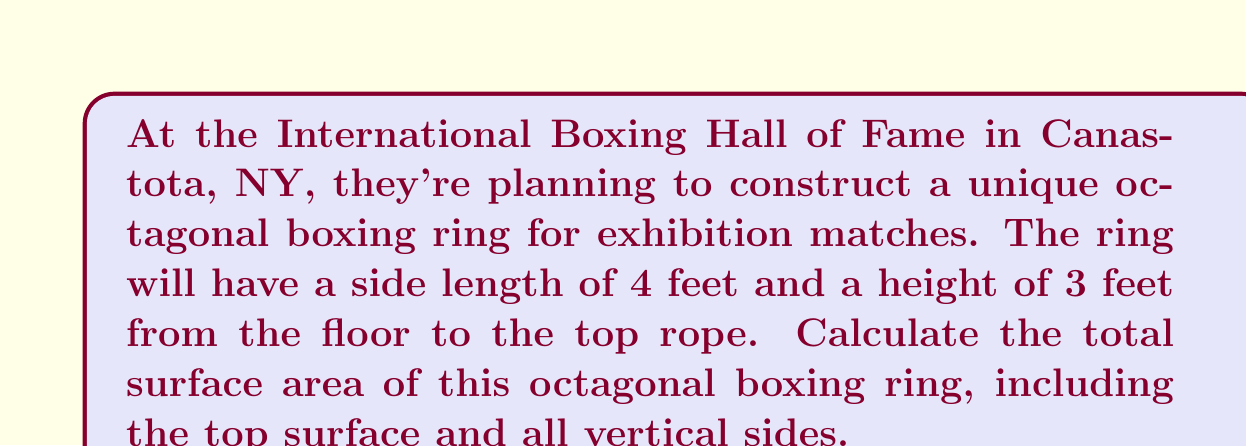Show me your answer to this math problem. Let's approach this step-by-step:

1) First, we need to calculate the area of the top surface of the octagonal ring.
   The area of a regular octagon is given by the formula:
   $$A_{octagon} = 2a^2(1 + \sqrt{2})$$
   where $a$ is the side length.

   With $a = 4$ feet:
   $$A_{top} = 2(4^2)(1 + \sqrt{2}) = 32(1 + \sqrt{2}) \approx 77.25 \text{ sq ft}$$

2) Next, we need to calculate the area of the vertical sides.
   The perimeter of the octagon is $8a$, so with a height of 3 feet:
   $$A_{sides} = 8a \cdot h = 8(4)(3) = 96 \text{ sq ft}$$

3) The total surface area is the sum of the top area and the side area:
   $$A_{total} = A_{top} + A_{sides} = 32(1 + \sqrt{2}) + 96$$

4) Simplifying:
   $$A_{total} = 32 + 32\sqrt{2} + 96 = 128 + 32\sqrt{2} \approx 173.25 \text{ sq ft}$$

Here's a visual representation of the octagonal ring:

[asy]
import geometry;

unitsize(20);
pair[] octagon;
for(int i=0; i<8; ++i) {
  octagon.push(4*dir(45*i));
}
draw(polygon(octagon), linewidth(1));
draw(shift(0,0,3)*polygon(octagon), linewidth(1));
for(int i=0; i<8; ++i) {
  draw((octagon[i])--(shift(0,0,3)*octagon[i]), linewidth(1));
}
label("4 ft", (2,2), NE);
label("3 ft", (4.5,0), E);
[/asy]
Answer: The total surface area of the octagonal boxing ring is $128 + 32\sqrt{2}$ square feet, or approximately 173.25 square feet. 